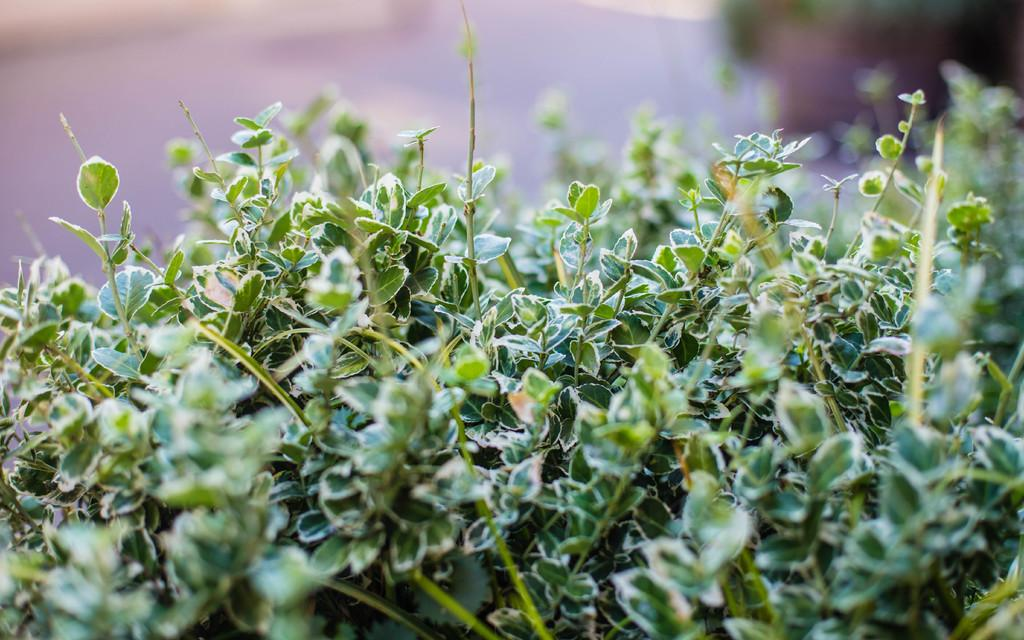What type of living organisms can be seen in the image? Plants can be seen in the image. What color are the leaves of the plants in the image? The leaves of the plants in the image are green. What type of wall can be seen in the image? There is no wall present in the image; it features plants with green leaves. What time of day is depicted in the image? The time of day cannot be determined from the image, as it only shows plants with green leaves. 